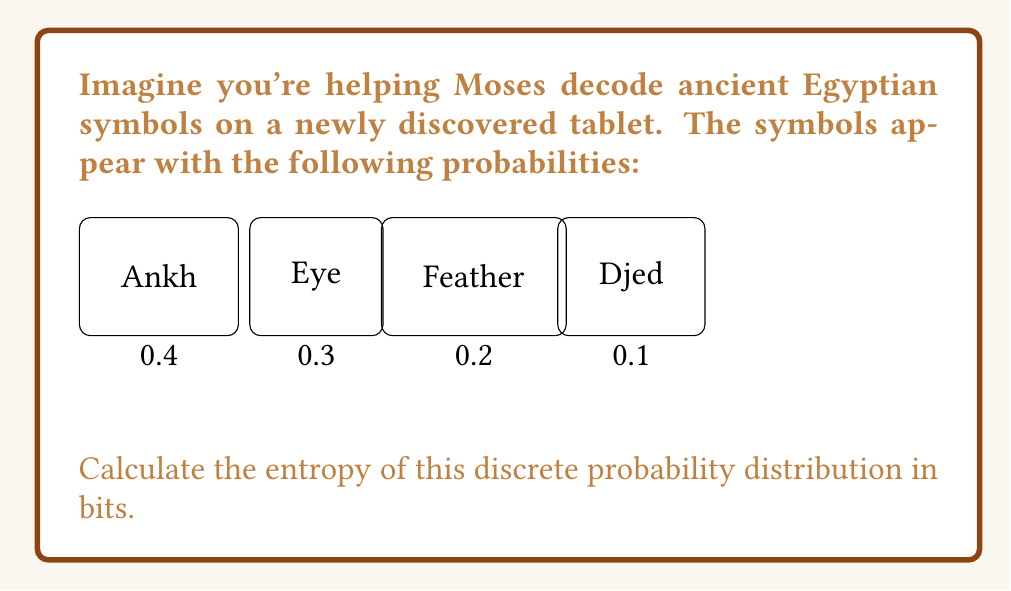Can you answer this question? To calculate the entropy of a discrete probability distribution, we use the formula:

$$H = -\sum_{i=1}^n p_i \log_2(p_i)$$

Where $p_i$ is the probability of each event and $n$ is the number of possible events.

Let's calculate each term:

1) For $p_1 = 0.4$:
   $-0.4 \log_2(0.4) = 0.4 \cdot 1.32 = 0.528$

2) For $p_2 = 0.3$:
   $-0.3 \log_2(0.3) = 0.3 \cdot 1.74 = 0.521$

3) For $p_3 = 0.2$:
   $-0.2 \log_2(0.2) = 0.2 \cdot 2.32 = 0.464$

4) For $p_4 = 0.1$:
   $-0.1 \log_2(0.1) = 0.1 \cdot 3.32 = 0.332$

Now, we sum all these terms:

$$H = 0.528 + 0.521 + 0.464 + 0.332 = 1.845$$

Therefore, the entropy of this discrete probability distribution is approximately 1.845 bits.
Answer: 1.845 bits 